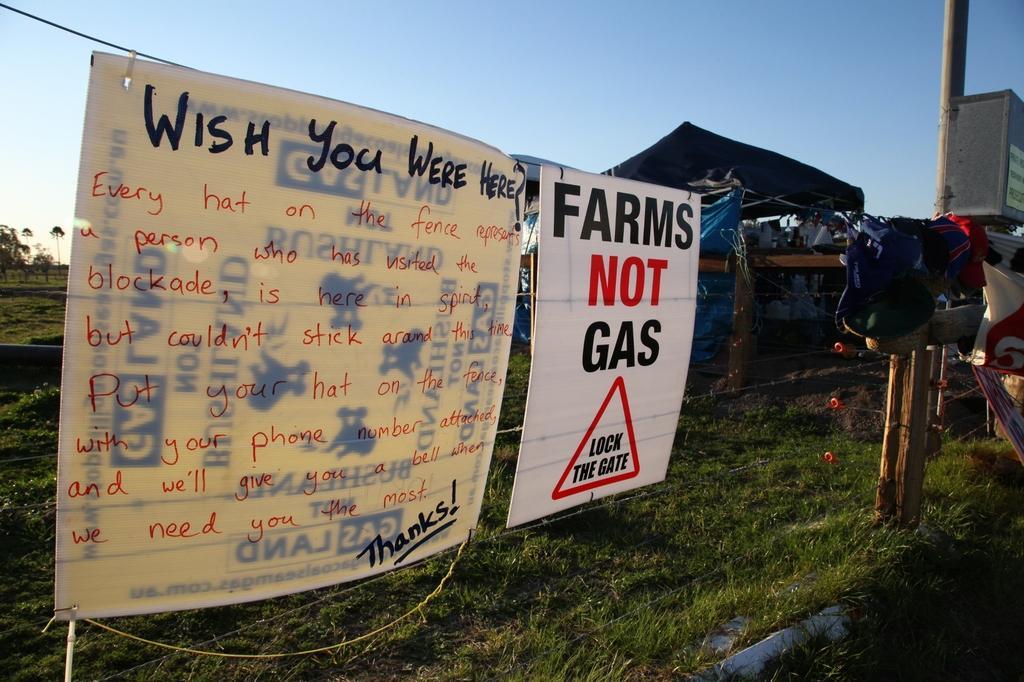Can you describe this image briefly? In this picture i can see the posters, cloth and bag which are hanging on this steel wire. At the bottom i can see the grass. On the right i can see the shade, wall and pole. At the top there is a sky. On the left background i can see the farmland, trees, plants and grass. 